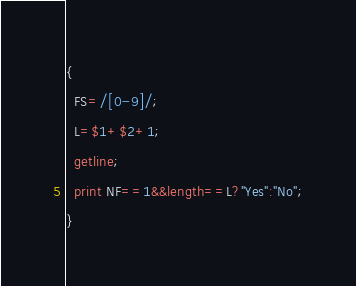<code> <loc_0><loc_0><loc_500><loc_500><_Awk_>{
  FS=/[0-9]/;
  L=$1+$2+1;
  getline;
  print NF==1&&length==L?"Yes":"No";
}</code> 